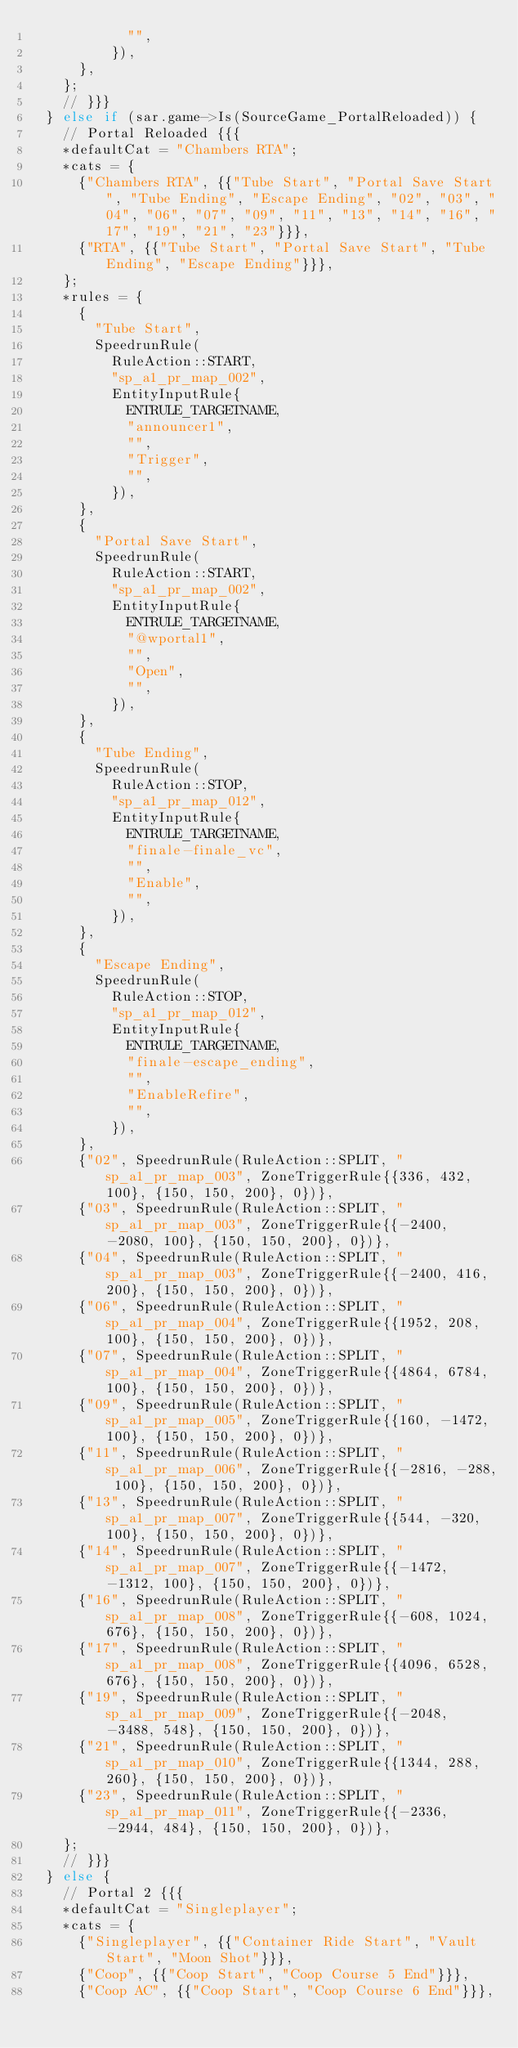<code> <loc_0><loc_0><loc_500><loc_500><_C++_>						"",
					}),
			},
		};
		// }}}
	} else if (sar.game->Is(SourceGame_PortalReloaded)) {
		// Portal Reloaded {{{
		*defaultCat = "Chambers RTA";
		*cats = {
			{"Chambers RTA", {{"Tube Start", "Portal Save Start", "Tube Ending", "Escape Ending", "02", "03", "04", "06", "07", "09", "11", "13", "14", "16", "17", "19", "21", "23"}}},
			{"RTA", {{"Tube Start", "Portal Save Start", "Tube Ending", "Escape Ending"}}},
		};
		*rules = {
			{
				"Tube Start",
				SpeedrunRule(
					RuleAction::START,
					"sp_a1_pr_map_002",
					EntityInputRule{
						ENTRULE_TARGETNAME,
						"announcer1",
						"",
						"Trigger",
						"",
					}),
			},
			{
				"Portal Save Start",
				SpeedrunRule(
					RuleAction::START,
					"sp_a1_pr_map_002",
					EntityInputRule{
						ENTRULE_TARGETNAME,
						"@wportal1",
						"",
						"Open",
						"",
					}),
			},
			{
				"Tube Ending",
				SpeedrunRule(
					RuleAction::STOP,
					"sp_a1_pr_map_012",
					EntityInputRule{
						ENTRULE_TARGETNAME,
						"finale-finale_vc",
						"",
						"Enable",
						"",
					}),
			},
			{
				"Escape Ending",
				SpeedrunRule(
					RuleAction::STOP,
					"sp_a1_pr_map_012",
					EntityInputRule{
						ENTRULE_TARGETNAME,
						"finale-escape_ending",
						"",
						"EnableRefire",
						"",
					}),
			},
			{"02", SpeedrunRule(RuleAction::SPLIT, "sp_a1_pr_map_003", ZoneTriggerRule{{336, 432, 100}, {150, 150, 200}, 0})},
			{"03", SpeedrunRule(RuleAction::SPLIT, "sp_a1_pr_map_003", ZoneTriggerRule{{-2400, -2080, 100}, {150, 150, 200}, 0})},
			{"04", SpeedrunRule(RuleAction::SPLIT, "sp_a1_pr_map_003", ZoneTriggerRule{{-2400, 416, 200}, {150, 150, 200}, 0})},
			{"06", SpeedrunRule(RuleAction::SPLIT, "sp_a1_pr_map_004", ZoneTriggerRule{{1952, 208, 100}, {150, 150, 200}, 0})},
			{"07", SpeedrunRule(RuleAction::SPLIT, "sp_a1_pr_map_004", ZoneTriggerRule{{4864, 6784, 100}, {150, 150, 200}, 0})},
			{"09", SpeedrunRule(RuleAction::SPLIT, "sp_a1_pr_map_005", ZoneTriggerRule{{160, -1472, 100}, {150, 150, 200}, 0})},
			{"11", SpeedrunRule(RuleAction::SPLIT, "sp_a1_pr_map_006", ZoneTriggerRule{{-2816, -288, 100}, {150, 150, 200}, 0})},
			{"13", SpeedrunRule(RuleAction::SPLIT, "sp_a1_pr_map_007", ZoneTriggerRule{{544, -320, 100}, {150, 150, 200}, 0})},
			{"14", SpeedrunRule(RuleAction::SPLIT, "sp_a1_pr_map_007", ZoneTriggerRule{{-1472, -1312, 100}, {150, 150, 200}, 0})},
			{"16", SpeedrunRule(RuleAction::SPLIT, "sp_a1_pr_map_008", ZoneTriggerRule{{-608, 1024, 676}, {150, 150, 200}, 0})},
			{"17", SpeedrunRule(RuleAction::SPLIT, "sp_a1_pr_map_008", ZoneTriggerRule{{4096, 6528, 676}, {150, 150, 200}, 0})},
			{"19", SpeedrunRule(RuleAction::SPLIT, "sp_a1_pr_map_009", ZoneTriggerRule{{-2048, -3488, 548}, {150, 150, 200}, 0})},
			{"21", SpeedrunRule(RuleAction::SPLIT, "sp_a1_pr_map_010", ZoneTriggerRule{{1344, 288, 260}, {150, 150, 200}, 0})},
			{"23", SpeedrunRule(RuleAction::SPLIT, "sp_a1_pr_map_011", ZoneTriggerRule{{-2336, -2944, 484}, {150, 150, 200}, 0})},
		};
		// }}}
	} else {
		// Portal 2 {{{
		*defaultCat = "Singleplayer";
		*cats = {
			{"Singleplayer", {{"Container Ride Start", "Vault Start", "Moon Shot"}}},
			{"Coop", {{"Coop Start", "Coop Course 5 End"}}},
			{"Coop AC", {{"Coop Start", "Coop Course 6 End"}}},</code> 